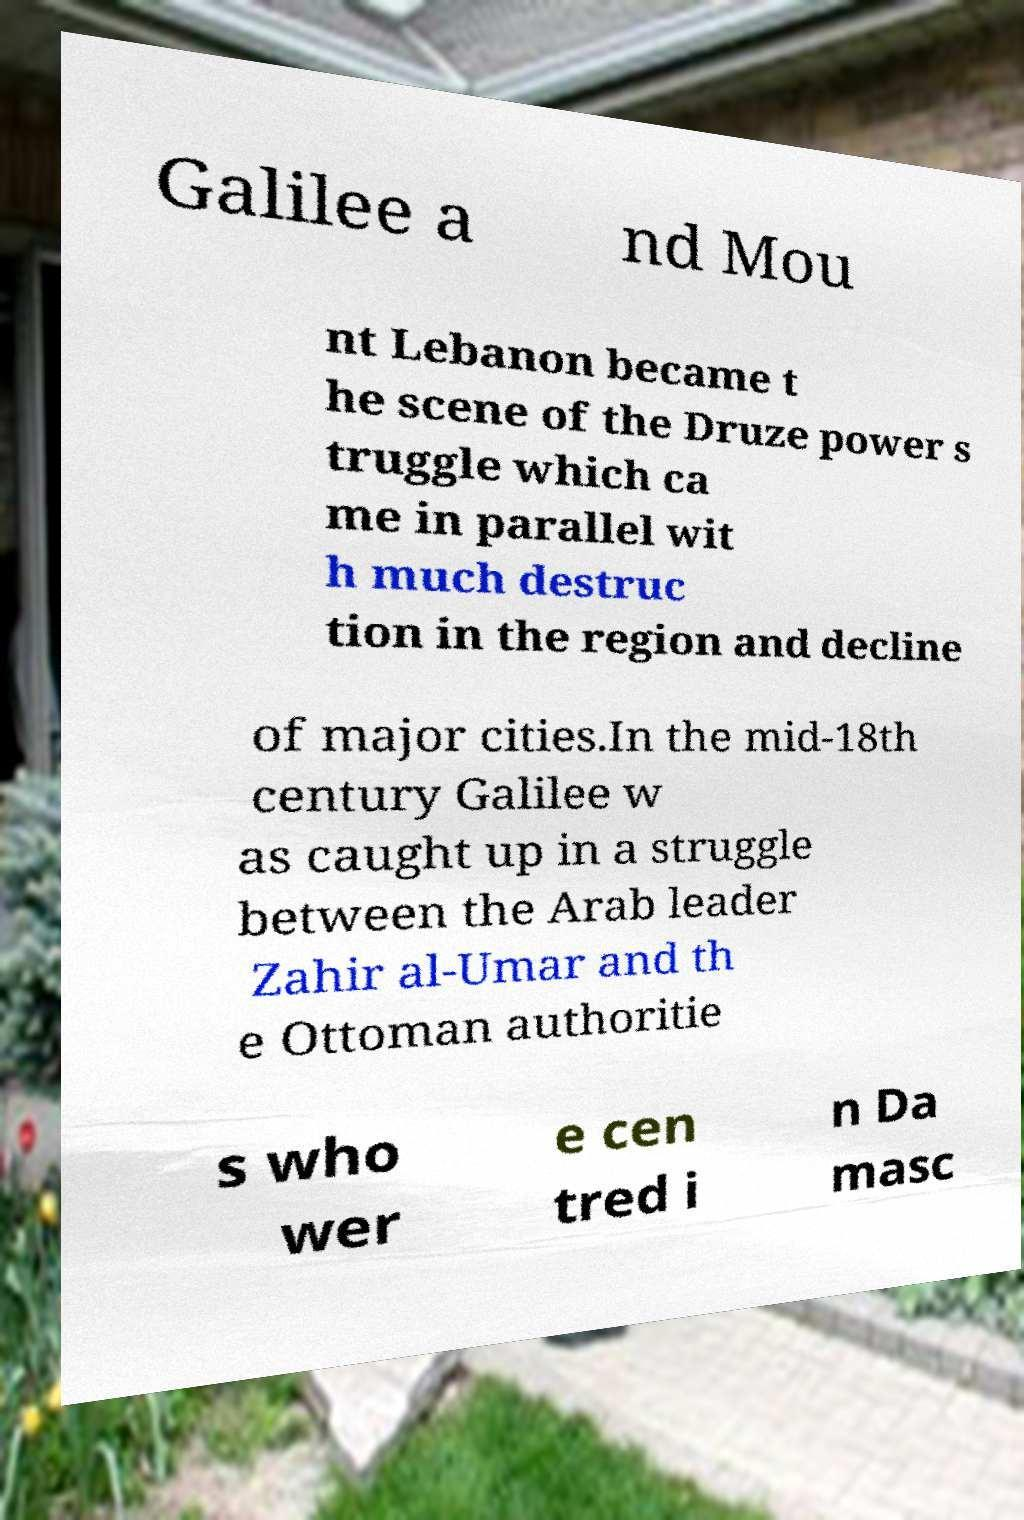What messages or text are displayed in this image? I need them in a readable, typed format. Galilee a nd Mou nt Lebanon became t he scene of the Druze power s truggle which ca me in parallel wit h much destruc tion in the region and decline of major cities.In the mid-18th century Galilee w as caught up in a struggle between the Arab leader Zahir al-Umar and th e Ottoman authoritie s who wer e cen tred i n Da masc 